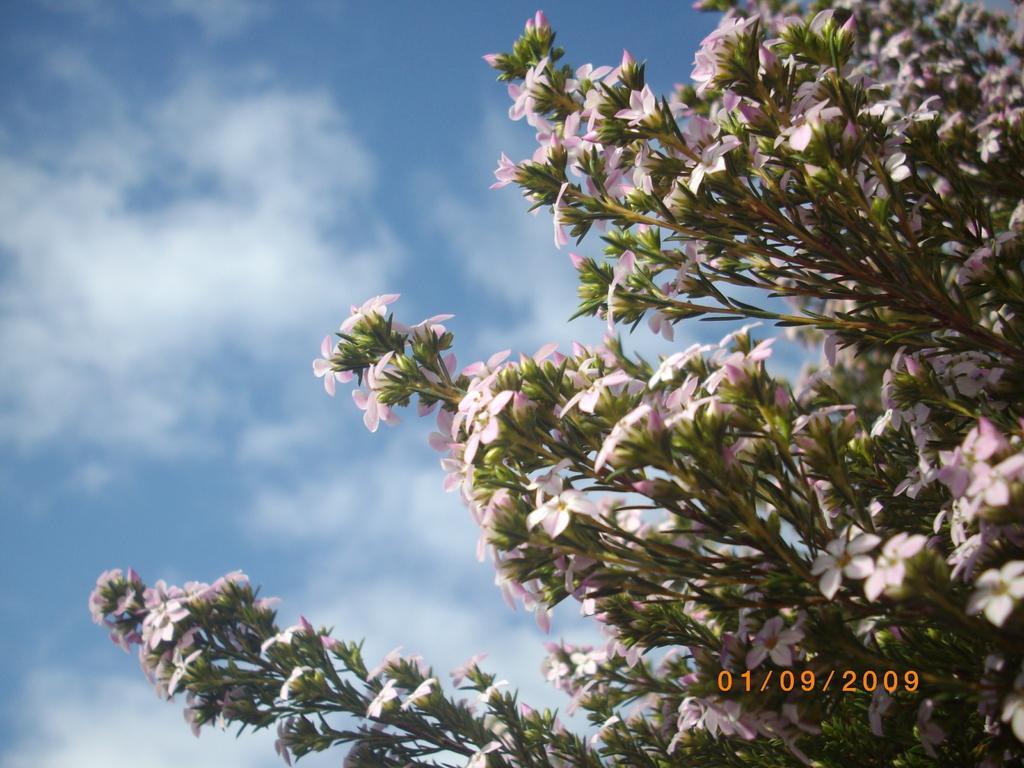Describe this image in one or two sentences. Here we can see plants with flowers. In the background there is sky with clouds. 